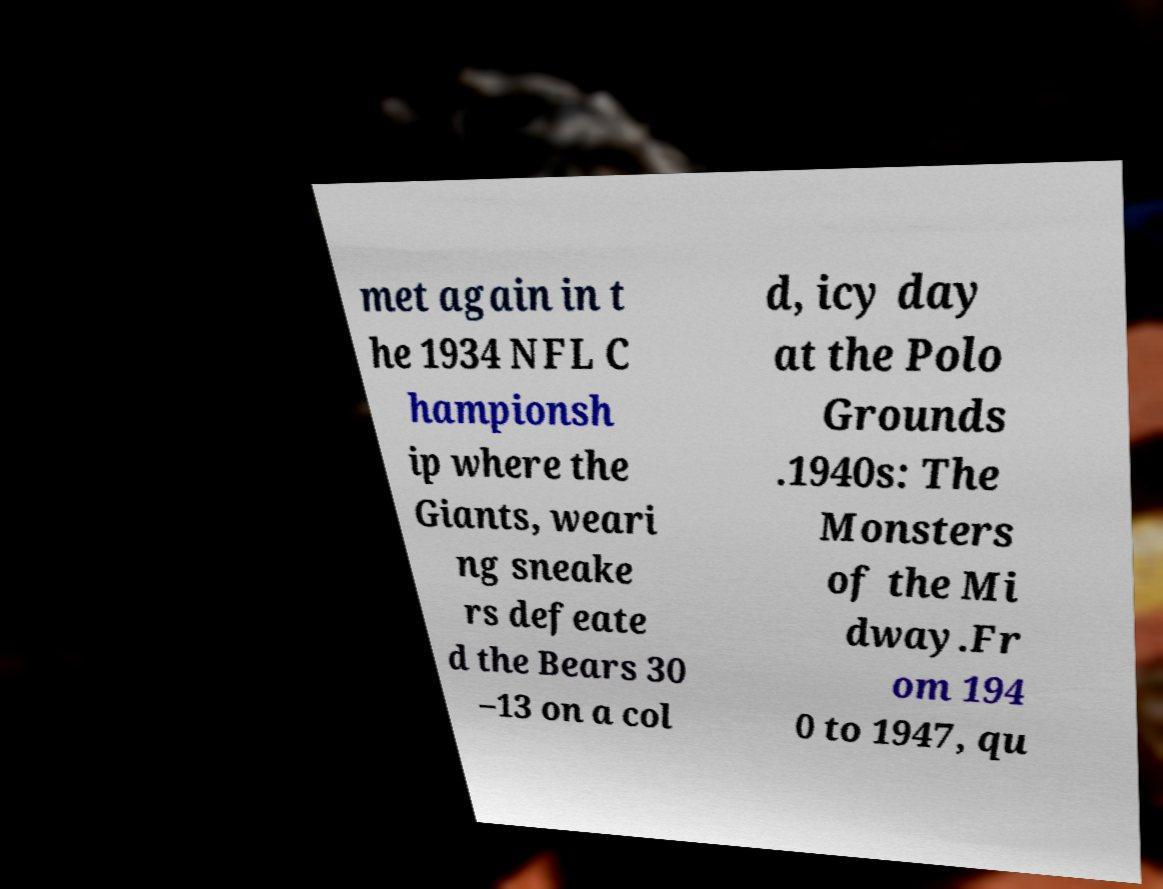I need the written content from this picture converted into text. Can you do that? met again in t he 1934 NFL C hampionsh ip where the Giants, weari ng sneake rs defeate d the Bears 30 –13 on a col d, icy day at the Polo Grounds .1940s: The Monsters of the Mi dway.Fr om 194 0 to 1947, qu 